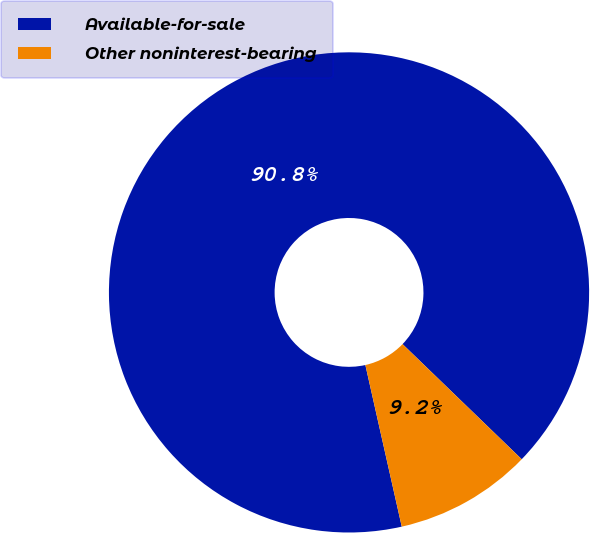<chart> <loc_0><loc_0><loc_500><loc_500><pie_chart><fcel>Available-for-sale<fcel>Other noninterest-bearing<nl><fcel>90.75%<fcel>9.25%<nl></chart> 